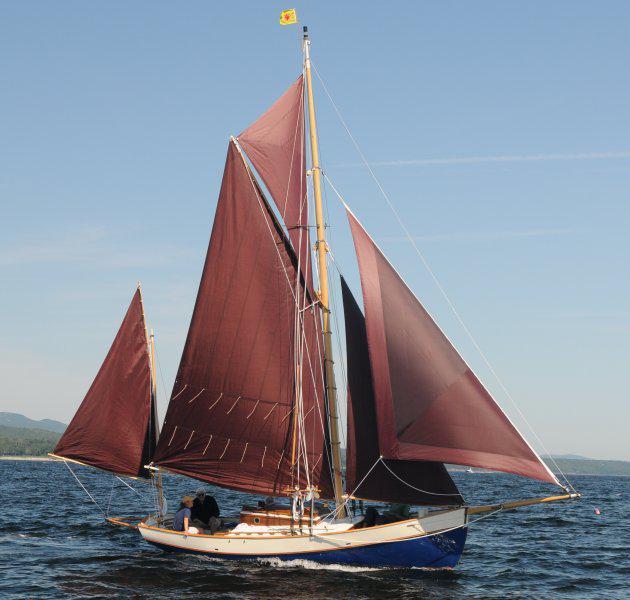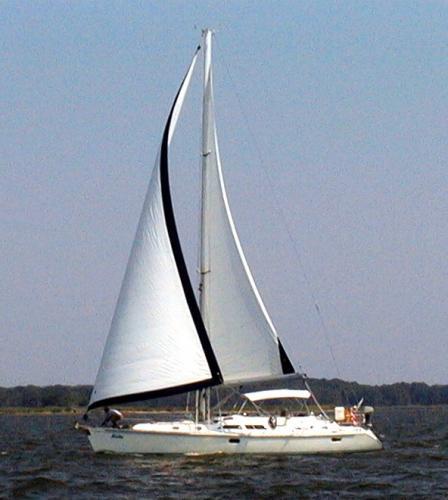The first image is the image on the left, the second image is the image on the right. Given the left and right images, does the statement "All boats have sails in the same colour." hold true? Answer yes or no. No. The first image is the image on the left, the second image is the image on the right. For the images shown, is this caption "A total of one sailboat with brown sails is pictured." true? Answer yes or no. Yes. 